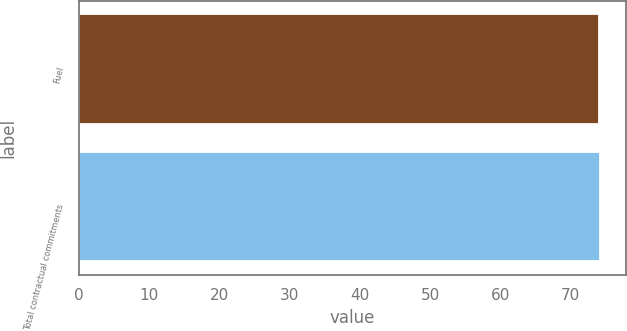Convert chart to OTSL. <chart><loc_0><loc_0><loc_500><loc_500><bar_chart><fcel>Fuel<fcel>Total contractual commitments<nl><fcel>74.1<fcel>74.2<nl></chart> 